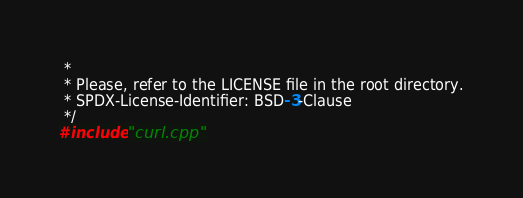<code> <loc_0><loc_0><loc_500><loc_500><_Cuda_> *
 * Please, refer to the LICENSE file in the root directory.
 * SPDX-License-Identifier: BSD-3-Clause
 */
#include "curl.cpp"
</code> 